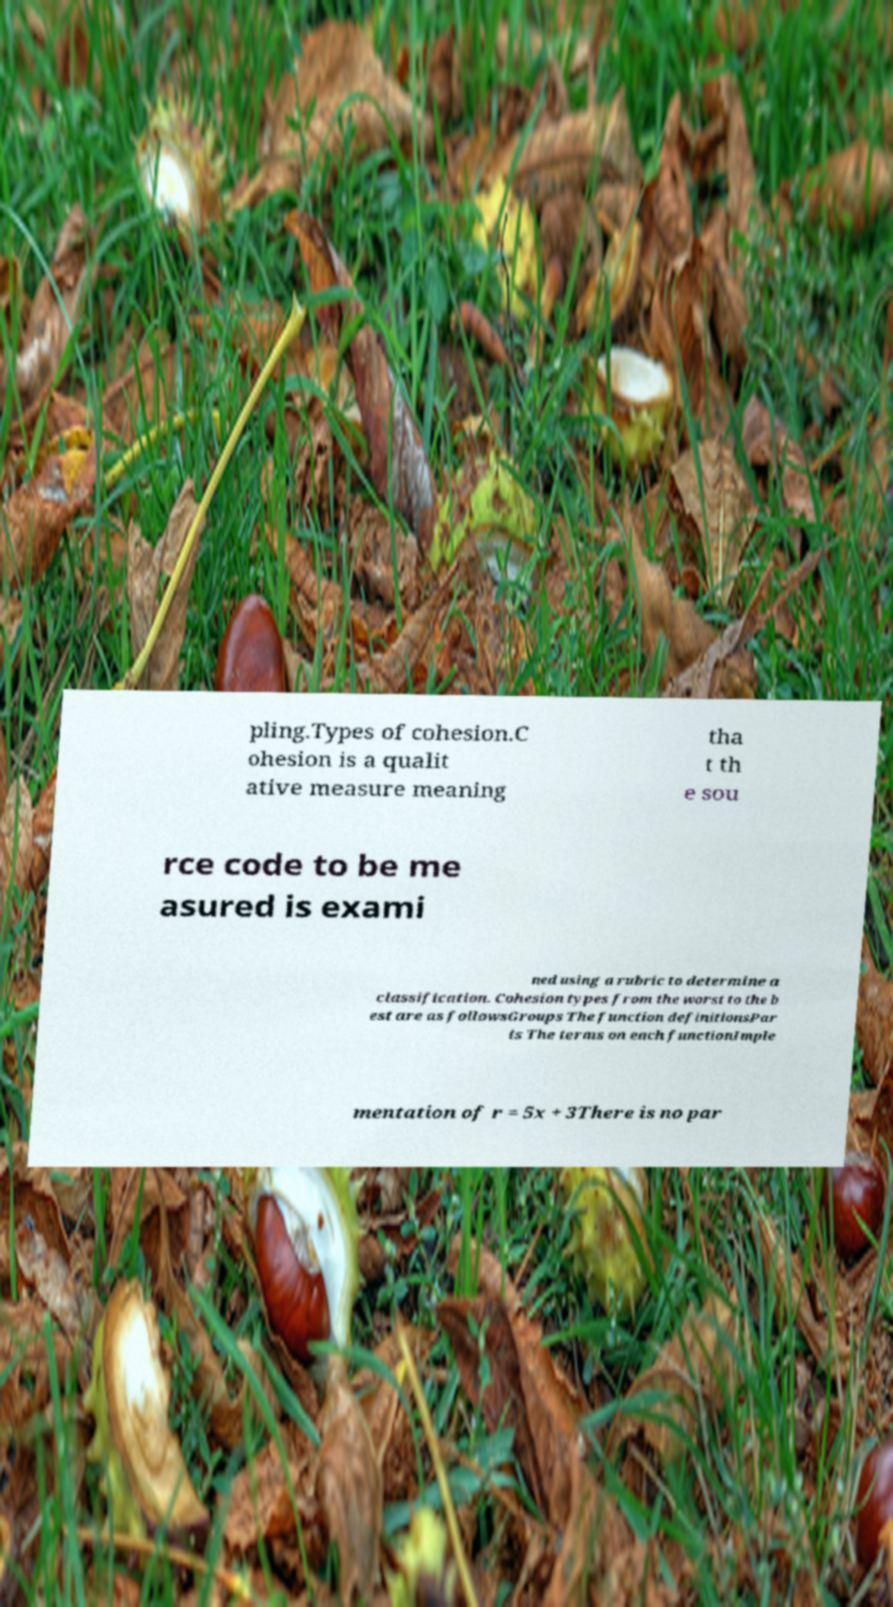Please read and relay the text visible in this image. What does it say? pling.Types of cohesion.C ohesion is a qualit ative measure meaning tha t th e sou rce code to be me asured is exami ned using a rubric to determine a classification. Cohesion types from the worst to the b est are as followsGroups The function definitionsPar ts The terms on each functionImple mentation of r = 5x + 3There is no par 